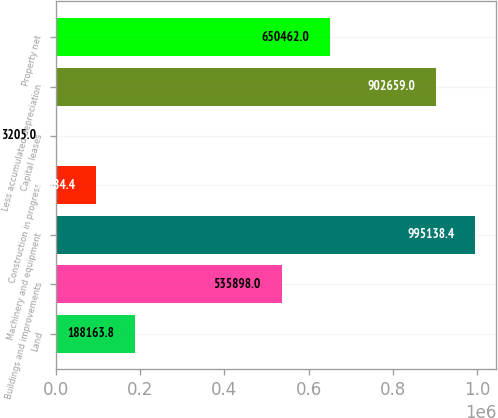Convert chart to OTSL. <chart><loc_0><loc_0><loc_500><loc_500><bar_chart><fcel>Land<fcel>Buildings and improvements<fcel>Machinery and equipment<fcel>Construction in progress<fcel>Capital leases<fcel>Less accumulated depreciation<fcel>Property net<nl><fcel>188164<fcel>535898<fcel>995138<fcel>95684.4<fcel>3205<fcel>902659<fcel>650462<nl></chart> 